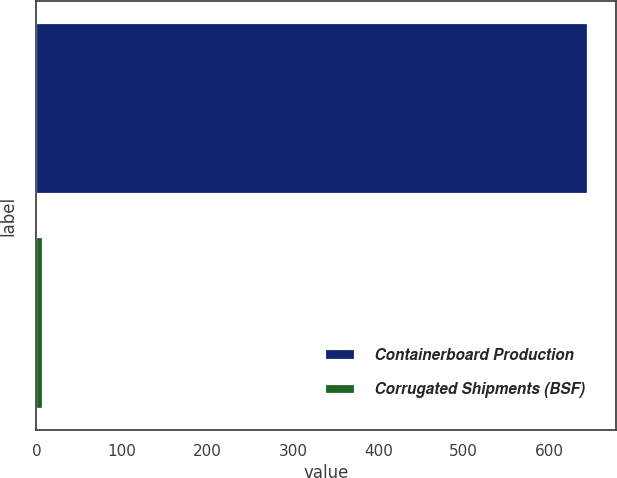Convert chart to OTSL. <chart><loc_0><loc_0><loc_500><loc_500><bar_chart><fcel>Containerboard Production<fcel>Corrugated Shipments (BSF)<nl><fcel>646<fcel>7.8<nl></chart> 